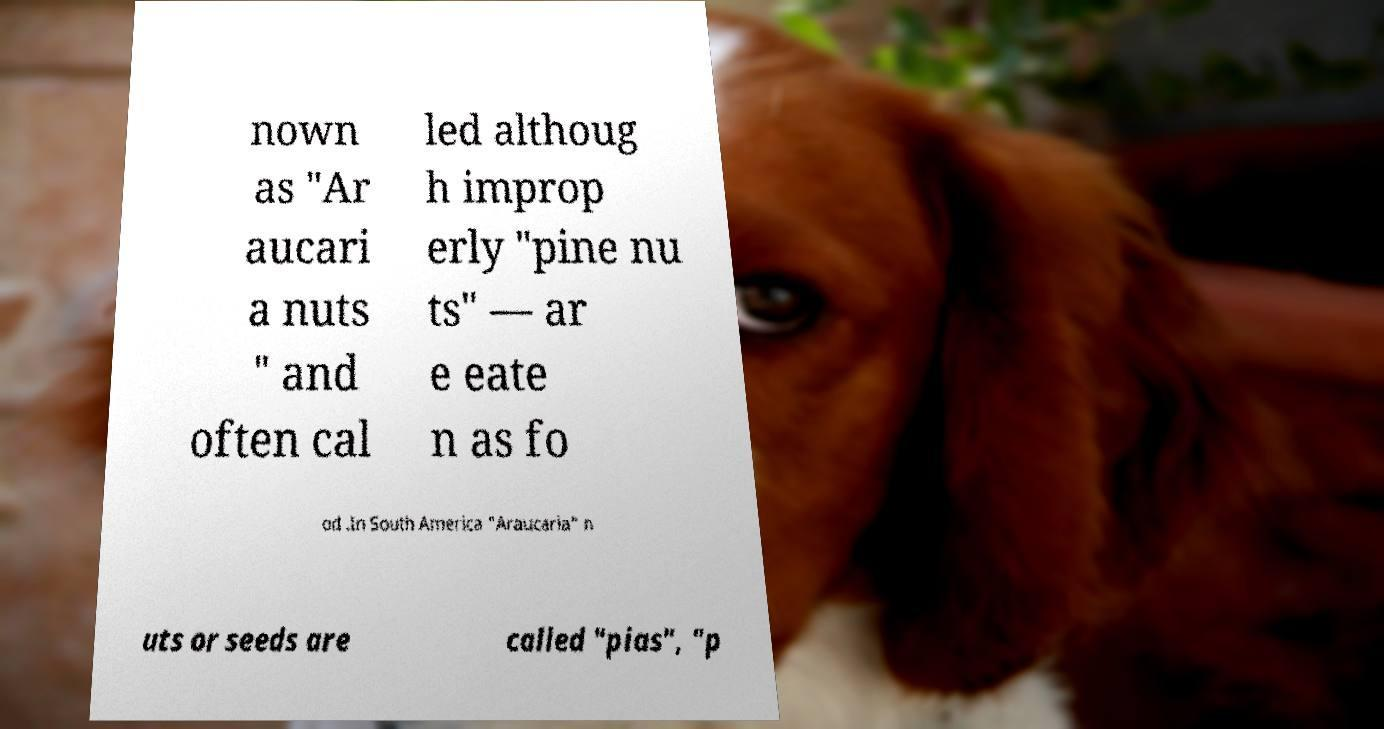What messages or text are displayed in this image? I need them in a readable, typed format. nown as "Ar aucari a nuts " and often cal led althoug h improp erly "pine nu ts" — ar e eate n as fo od .In South America "Araucaria" n uts or seeds are called "pias", "p 